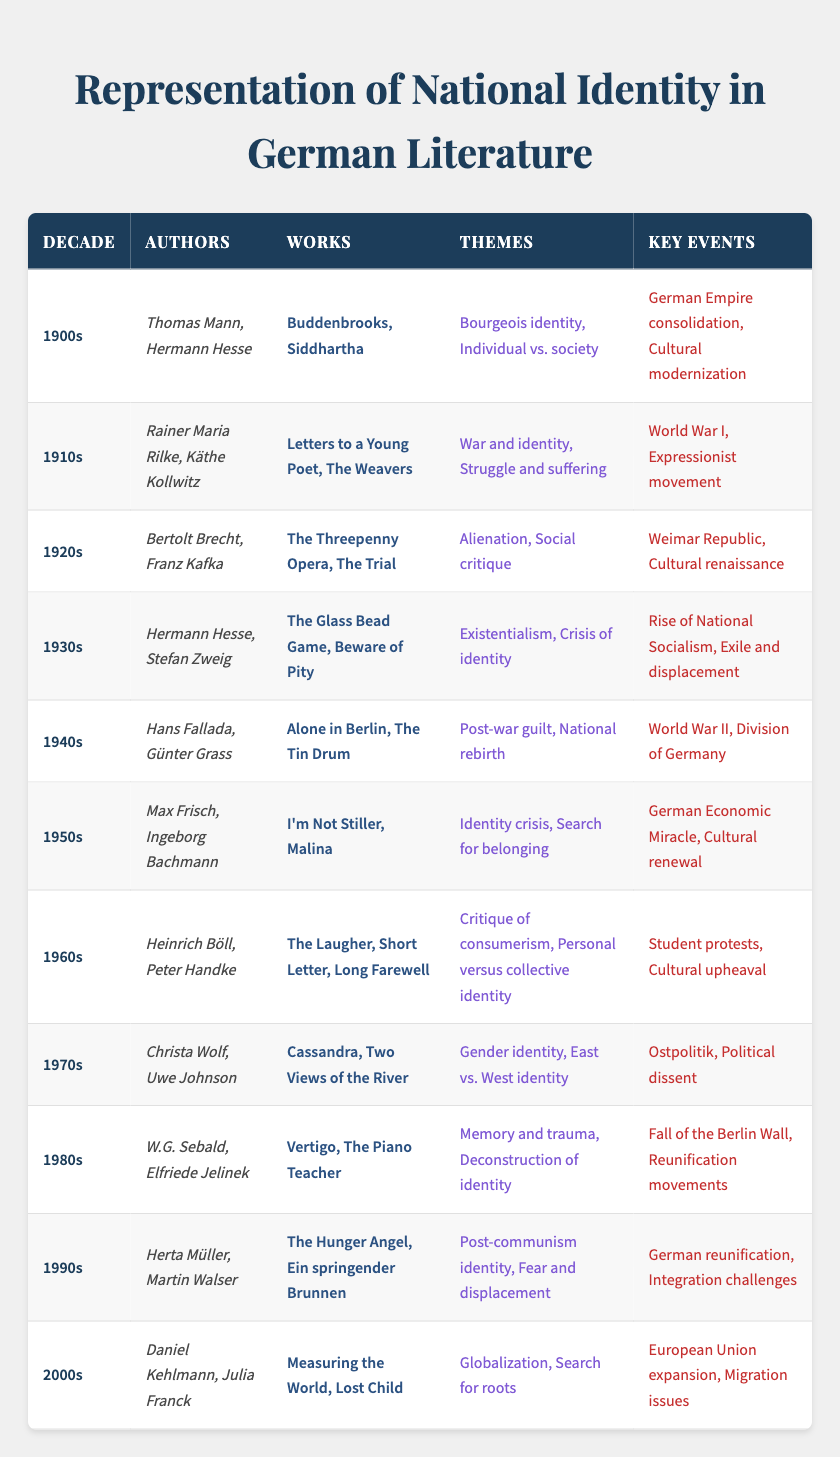What authors are associated with the 1940s? The 1940s section of the table lists "Hans Fallada" and "Günter Grass" as the authors representing that decade.
Answer: Hans Fallada, Günter Grass Which theme is associated with literature from the 1960s? According to the table, the themes associated with the 1960s include "Critique of consumerism" and "Personal versus collective identity."
Answer: Critique of consumerism, Personal versus collective identity In which decade did the rise of National Socialism occur? The table indicates that the rise of National Socialism is a key event in the 1930s.
Answer: 1930s Can you list any works by authors from the 1980s? The 1980s section provides "Vertigo" by W.G. Sebald and "The Piano Teacher" by Elfriede Jelinek as notable works.
Answer: Vertigo, The Piano Teacher Which decade featured authors who dealt with the theme of "Post-war guilt"? The theme of "Post-war guilt" is found in the 1940s section of the table.
Answer: 1940s What was a key event in the 1920s? The table specifies "Weimar Republic" and "Cultural renaissance" as key events for the 1920s.
Answer: Weimar Republic, Cultural renaissance Which authors are mentioned during the 1910s and what themes did they explore? The authors listed for the 1910s are Rainer Maria Rilke and Käthe Kollwitz, and they explored themes of "War and identity" and "Struggle and suffering."
Answer: Rainer Maria Rilke, Käthe Kollwitz; War and identity, Struggle and suffering How does the theme of identity crisis evolve from the 1950s to the 1960s? In the 1950s, the theme is "Identity crisis," while by the 1960s, the focus shifts to "Critique of consumerism" and "Personal versus collective identity," suggesting a transition from personal struggles to broader societal critiques.
Answer: Transition from personal identity crisis to societal critiques Which two decades prominently featured themes of identity? The 1950s (Identity crisis) and the 1970s (East vs. West identity) prominently featured themes of identity based on the table.
Answer: 1950s, 1970s Was "The Glass Bead Game" published in the 1930s or 1940s? The table states that "The Glass Bead Game" was published in the 1930s, confirming that it was not published in the 1940s.
Answer: 1930s Identify the authors from the 2000s and describe the common theme they share. The authors from the 2000s are Daniel Kehlmann and Julia Franck, and they share the common theme of "Globalization" and "Search for roots."
Answer: Daniel Kehlmann, Julia Franck; Globalization, Search for roots How many different authors are mentioned in the 1980s? The table lists two authors from the 1980s: W.G. Sebald and Elfriede Jelinek, so the count is two authors.
Answer: 2 Which decade had the most significant exploration of gender identity? The 1970s is noted for exploring "Gender identity" along with "East vs. West identity," making it the decade with significant exploration of gender identity.
Answer: 1970s Did literature in the 1940s focus on national rebirth following World War II? Yes, the literature in the 1940s indeed focused on "Post-war guilt" and "National rebirth," highlighting the societal shift after World War II.
Answer: Yes 